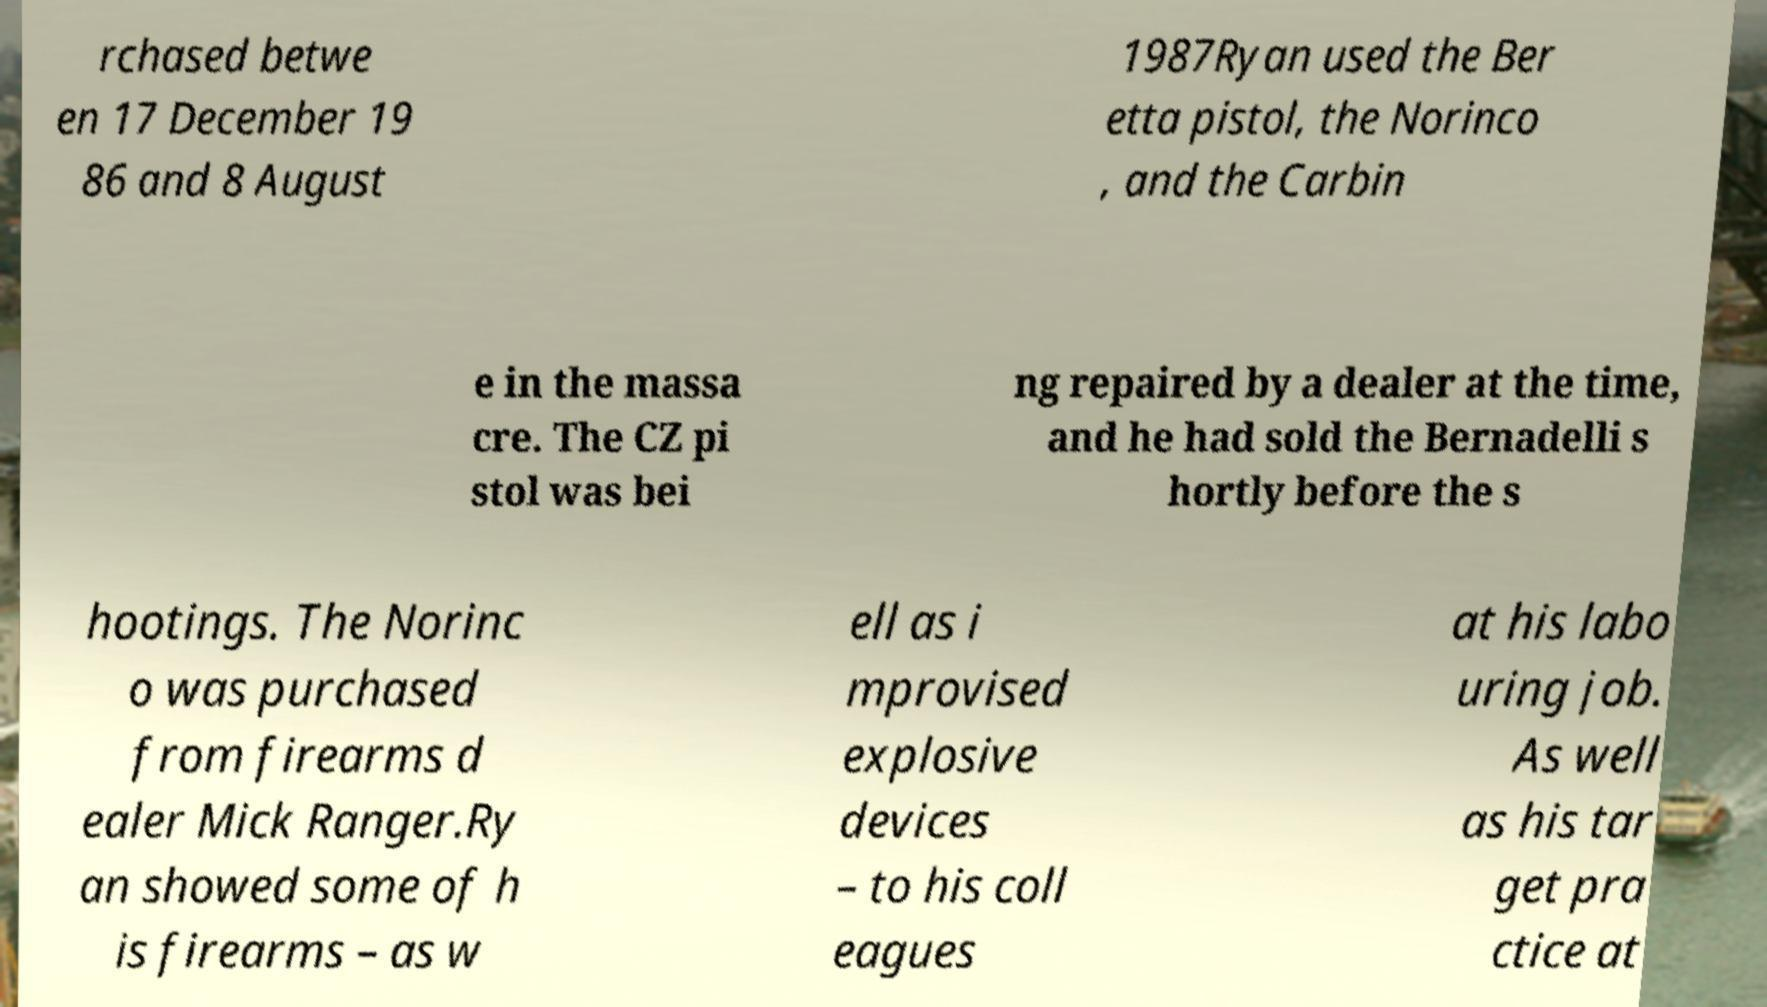Please read and relay the text visible in this image. What does it say? rchased betwe en 17 December 19 86 and 8 August 1987Ryan used the Ber etta pistol, the Norinco , and the Carbin e in the massa cre. The CZ pi stol was bei ng repaired by a dealer at the time, and he had sold the Bernadelli s hortly before the s hootings. The Norinc o was purchased from firearms d ealer Mick Ranger.Ry an showed some of h is firearms – as w ell as i mprovised explosive devices – to his coll eagues at his labo uring job. As well as his tar get pra ctice at 